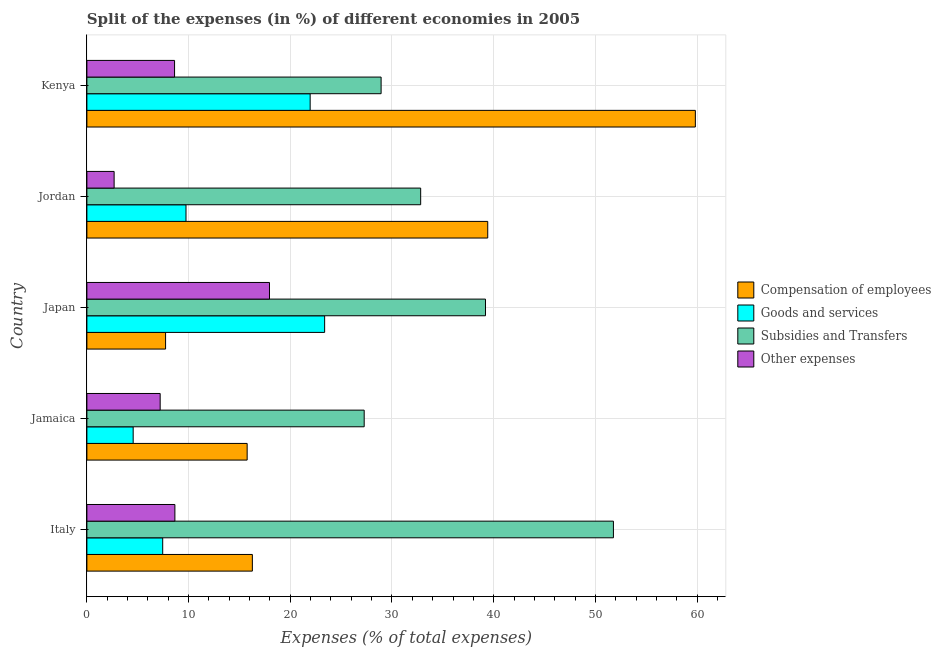Are the number of bars per tick equal to the number of legend labels?
Make the answer very short. Yes. How many bars are there on the 1st tick from the bottom?
Ensure brevity in your answer.  4. What is the label of the 4th group of bars from the top?
Your response must be concise. Jamaica. What is the percentage of amount spent on compensation of employees in Kenya?
Offer a terse response. 59.83. Across all countries, what is the maximum percentage of amount spent on goods and services?
Ensure brevity in your answer.  23.38. Across all countries, what is the minimum percentage of amount spent on compensation of employees?
Provide a succinct answer. 7.74. In which country was the percentage of amount spent on other expenses maximum?
Keep it short and to the point. Japan. In which country was the percentage of amount spent on other expenses minimum?
Ensure brevity in your answer.  Jordan. What is the total percentage of amount spent on goods and services in the graph?
Offer a very short reply. 67.08. What is the difference between the percentage of amount spent on goods and services in Jordan and that in Kenya?
Provide a short and direct response. -12.21. What is the difference between the percentage of amount spent on subsidies in Jordan and the percentage of amount spent on other expenses in Italy?
Keep it short and to the point. 24.17. What is the average percentage of amount spent on subsidies per country?
Make the answer very short. 36. What is the difference between the percentage of amount spent on subsidies and percentage of amount spent on other expenses in Jamaica?
Make the answer very short. 20.06. In how many countries, is the percentage of amount spent on subsidies greater than 54 %?
Provide a succinct answer. 0. What is the ratio of the percentage of amount spent on other expenses in Jordan to that in Kenya?
Ensure brevity in your answer.  0.31. Is the percentage of amount spent on goods and services in Jordan less than that in Kenya?
Ensure brevity in your answer.  Yes. What is the difference between the highest and the second highest percentage of amount spent on compensation of employees?
Make the answer very short. 20.42. What is the difference between the highest and the lowest percentage of amount spent on goods and services?
Offer a very short reply. 18.83. Is the sum of the percentage of amount spent on subsidies in Italy and Jordan greater than the maximum percentage of amount spent on goods and services across all countries?
Provide a succinct answer. Yes. Is it the case that in every country, the sum of the percentage of amount spent on compensation of employees and percentage of amount spent on other expenses is greater than the sum of percentage of amount spent on goods and services and percentage of amount spent on subsidies?
Give a very brief answer. Yes. What does the 2nd bar from the top in Italy represents?
Keep it short and to the point. Subsidies and Transfers. What does the 2nd bar from the bottom in Japan represents?
Provide a short and direct response. Goods and services. How many bars are there?
Provide a short and direct response. 20. Are all the bars in the graph horizontal?
Provide a short and direct response. Yes. What is the difference between two consecutive major ticks on the X-axis?
Give a very brief answer. 10. Does the graph contain any zero values?
Provide a succinct answer. No. Does the graph contain grids?
Offer a very short reply. Yes. Where does the legend appear in the graph?
Offer a terse response. Center right. How many legend labels are there?
Keep it short and to the point. 4. How are the legend labels stacked?
Provide a short and direct response. Vertical. What is the title of the graph?
Keep it short and to the point. Split of the expenses (in %) of different economies in 2005. Does "UNDP" appear as one of the legend labels in the graph?
Your answer should be compact. No. What is the label or title of the X-axis?
Keep it short and to the point. Expenses (% of total expenses). What is the label or title of the Y-axis?
Keep it short and to the point. Country. What is the Expenses (% of total expenses) in Compensation of employees in Italy?
Your response must be concise. 16.27. What is the Expenses (% of total expenses) in Goods and services in Italy?
Your answer should be compact. 7.46. What is the Expenses (% of total expenses) in Subsidies and Transfers in Italy?
Make the answer very short. 51.77. What is the Expenses (% of total expenses) in Other expenses in Italy?
Ensure brevity in your answer.  8.65. What is the Expenses (% of total expenses) in Compensation of employees in Jamaica?
Ensure brevity in your answer.  15.76. What is the Expenses (% of total expenses) of Goods and services in Jamaica?
Give a very brief answer. 4.55. What is the Expenses (% of total expenses) in Subsidies and Transfers in Jamaica?
Your answer should be compact. 27.27. What is the Expenses (% of total expenses) of Other expenses in Jamaica?
Offer a very short reply. 7.2. What is the Expenses (% of total expenses) in Compensation of employees in Japan?
Your answer should be very brief. 7.74. What is the Expenses (% of total expenses) of Goods and services in Japan?
Offer a terse response. 23.38. What is the Expenses (% of total expenses) in Subsidies and Transfers in Japan?
Give a very brief answer. 39.19. What is the Expenses (% of total expenses) of Other expenses in Japan?
Provide a short and direct response. 17.95. What is the Expenses (% of total expenses) in Compensation of employees in Jordan?
Your response must be concise. 39.41. What is the Expenses (% of total expenses) of Goods and services in Jordan?
Your answer should be very brief. 9.74. What is the Expenses (% of total expenses) of Subsidies and Transfers in Jordan?
Provide a short and direct response. 32.82. What is the Expenses (% of total expenses) of Other expenses in Jordan?
Your response must be concise. 2.68. What is the Expenses (% of total expenses) in Compensation of employees in Kenya?
Your answer should be compact. 59.83. What is the Expenses (% of total expenses) of Goods and services in Kenya?
Your response must be concise. 21.95. What is the Expenses (% of total expenses) of Subsidies and Transfers in Kenya?
Your answer should be compact. 28.93. What is the Expenses (% of total expenses) of Other expenses in Kenya?
Provide a succinct answer. 8.62. Across all countries, what is the maximum Expenses (% of total expenses) of Compensation of employees?
Offer a very short reply. 59.83. Across all countries, what is the maximum Expenses (% of total expenses) in Goods and services?
Provide a succinct answer. 23.38. Across all countries, what is the maximum Expenses (% of total expenses) in Subsidies and Transfers?
Provide a succinct answer. 51.77. Across all countries, what is the maximum Expenses (% of total expenses) of Other expenses?
Your answer should be compact. 17.95. Across all countries, what is the minimum Expenses (% of total expenses) of Compensation of employees?
Keep it short and to the point. 7.74. Across all countries, what is the minimum Expenses (% of total expenses) in Goods and services?
Your answer should be compact. 4.55. Across all countries, what is the minimum Expenses (% of total expenses) in Subsidies and Transfers?
Offer a very short reply. 27.27. Across all countries, what is the minimum Expenses (% of total expenses) in Other expenses?
Make the answer very short. 2.68. What is the total Expenses (% of total expenses) of Compensation of employees in the graph?
Provide a short and direct response. 139.01. What is the total Expenses (% of total expenses) of Goods and services in the graph?
Keep it short and to the point. 67.08. What is the total Expenses (% of total expenses) in Subsidies and Transfers in the graph?
Your answer should be very brief. 179.99. What is the total Expenses (% of total expenses) in Other expenses in the graph?
Your answer should be compact. 45.11. What is the difference between the Expenses (% of total expenses) in Compensation of employees in Italy and that in Jamaica?
Your answer should be compact. 0.51. What is the difference between the Expenses (% of total expenses) of Goods and services in Italy and that in Jamaica?
Make the answer very short. 2.9. What is the difference between the Expenses (% of total expenses) in Subsidies and Transfers in Italy and that in Jamaica?
Ensure brevity in your answer.  24.51. What is the difference between the Expenses (% of total expenses) in Other expenses in Italy and that in Jamaica?
Ensure brevity in your answer.  1.45. What is the difference between the Expenses (% of total expenses) in Compensation of employees in Italy and that in Japan?
Ensure brevity in your answer.  8.53. What is the difference between the Expenses (% of total expenses) in Goods and services in Italy and that in Japan?
Give a very brief answer. -15.92. What is the difference between the Expenses (% of total expenses) in Subsidies and Transfers in Italy and that in Japan?
Your response must be concise. 12.58. What is the difference between the Expenses (% of total expenses) of Other expenses in Italy and that in Japan?
Provide a short and direct response. -9.3. What is the difference between the Expenses (% of total expenses) in Compensation of employees in Italy and that in Jordan?
Keep it short and to the point. -23.14. What is the difference between the Expenses (% of total expenses) of Goods and services in Italy and that in Jordan?
Your answer should be very brief. -2.29. What is the difference between the Expenses (% of total expenses) in Subsidies and Transfers in Italy and that in Jordan?
Make the answer very short. 18.95. What is the difference between the Expenses (% of total expenses) of Other expenses in Italy and that in Jordan?
Offer a very short reply. 5.97. What is the difference between the Expenses (% of total expenses) of Compensation of employees in Italy and that in Kenya?
Offer a terse response. -43.56. What is the difference between the Expenses (% of total expenses) in Goods and services in Italy and that in Kenya?
Your response must be concise. -14.5. What is the difference between the Expenses (% of total expenses) in Subsidies and Transfers in Italy and that in Kenya?
Offer a terse response. 22.84. What is the difference between the Expenses (% of total expenses) of Other expenses in Italy and that in Kenya?
Your response must be concise. 0.03. What is the difference between the Expenses (% of total expenses) in Compensation of employees in Jamaica and that in Japan?
Your response must be concise. 8.02. What is the difference between the Expenses (% of total expenses) of Goods and services in Jamaica and that in Japan?
Ensure brevity in your answer.  -18.83. What is the difference between the Expenses (% of total expenses) in Subsidies and Transfers in Jamaica and that in Japan?
Keep it short and to the point. -11.93. What is the difference between the Expenses (% of total expenses) in Other expenses in Jamaica and that in Japan?
Keep it short and to the point. -10.75. What is the difference between the Expenses (% of total expenses) in Compensation of employees in Jamaica and that in Jordan?
Your answer should be very brief. -23.66. What is the difference between the Expenses (% of total expenses) of Goods and services in Jamaica and that in Jordan?
Offer a very short reply. -5.19. What is the difference between the Expenses (% of total expenses) in Subsidies and Transfers in Jamaica and that in Jordan?
Your answer should be very brief. -5.55. What is the difference between the Expenses (% of total expenses) of Other expenses in Jamaica and that in Jordan?
Make the answer very short. 4.53. What is the difference between the Expenses (% of total expenses) of Compensation of employees in Jamaica and that in Kenya?
Ensure brevity in your answer.  -44.07. What is the difference between the Expenses (% of total expenses) in Goods and services in Jamaica and that in Kenya?
Ensure brevity in your answer.  -17.4. What is the difference between the Expenses (% of total expenses) of Subsidies and Transfers in Jamaica and that in Kenya?
Keep it short and to the point. -1.66. What is the difference between the Expenses (% of total expenses) in Other expenses in Jamaica and that in Kenya?
Your answer should be very brief. -1.42. What is the difference between the Expenses (% of total expenses) of Compensation of employees in Japan and that in Jordan?
Provide a succinct answer. -31.68. What is the difference between the Expenses (% of total expenses) of Goods and services in Japan and that in Jordan?
Make the answer very short. 13.63. What is the difference between the Expenses (% of total expenses) in Subsidies and Transfers in Japan and that in Jordan?
Provide a succinct answer. 6.37. What is the difference between the Expenses (% of total expenses) in Other expenses in Japan and that in Jordan?
Your answer should be compact. 15.28. What is the difference between the Expenses (% of total expenses) in Compensation of employees in Japan and that in Kenya?
Offer a very short reply. -52.09. What is the difference between the Expenses (% of total expenses) in Goods and services in Japan and that in Kenya?
Your answer should be very brief. 1.43. What is the difference between the Expenses (% of total expenses) in Subsidies and Transfers in Japan and that in Kenya?
Give a very brief answer. 10.26. What is the difference between the Expenses (% of total expenses) in Other expenses in Japan and that in Kenya?
Ensure brevity in your answer.  9.33. What is the difference between the Expenses (% of total expenses) in Compensation of employees in Jordan and that in Kenya?
Your response must be concise. -20.42. What is the difference between the Expenses (% of total expenses) in Goods and services in Jordan and that in Kenya?
Keep it short and to the point. -12.21. What is the difference between the Expenses (% of total expenses) in Subsidies and Transfers in Jordan and that in Kenya?
Your answer should be compact. 3.89. What is the difference between the Expenses (% of total expenses) in Other expenses in Jordan and that in Kenya?
Your response must be concise. -5.94. What is the difference between the Expenses (% of total expenses) in Compensation of employees in Italy and the Expenses (% of total expenses) in Goods and services in Jamaica?
Your answer should be very brief. 11.72. What is the difference between the Expenses (% of total expenses) in Compensation of employees in Italy and the Expenses (% of total expenses) in Subsidies and Transfers in Jamaica?
Your response must be concise. -11. What is the difference between the Expenses (% of total expenses) in Compensation of employees in Italy and the Expenses (% of total expenses) in Other expenses in Jamaica?
Keep it short and to the point. 9.07. What is the difference between the Expenses (% of total expenses) in Goods and services in Italy and the Expenses (% of total expenses) in Subsidies and Transfers in Jamaica?
Keep it short and to the point. -19.81. What is the difference between the Expenses (% of total expenses) of Goods and services in Italy and the Expenses (% of total expenses) of Other expenses in Jamaica?
Your answer should be compact. 0.25. What is the difference between the Expenses (% of total expenses) of Subsidies and Transfers in Italy and the Expenses (% of total expenses) of Other expenses in Jamaica?
Give a very brief answer. 44.57. What is the difference between the Expenses (% of total expenses) of Compensation of employees in Italy and the Expenses (% of total expenses) of Goods and services in Japan?
Offer a terse response. -7.11. What is the difference between the Expenses (% of total expenses) of Compensation of employees in Italy and the Expenses (% of total expenses) of Subsidies and Transfers in Japan?
Ensure brevity in your answer.  -22.92. What is the difference between the Expenses (% of total expenses) in Compensation of employees in Italy and the Expenses (% of total expenses) in Other expenses in Japan?
Your answer should be compact. -1.68. What is the difference between the Expenses (% of total expenses) in Goods and services in Italy and the Expenses (% of total expenses) in Subsidies and Transfers in Japan?
Keep it short and to the point. -31.74. What is the difference between the Expenses (% of total expenses) in Goods and services in Italy and the Expenses (% of total expenses) in Other expenses in Japan?
Offer a terse response. -10.5. What is the difference between the Expenses (% of total expenses) in Subsidies and Transfers in Italy and the Expenses (% of total expenses) in Other expenses in Japan?
Offer a terse response. 33.82. What is the difference between the Expenses (% of total expenses) of Compensation of employees in Italy and the Expenses (% of total expenses) of Goods and services in Jordan?
Make the answer very short. 6.53. What is the difference between the Expenses (% of total expenses) in Compensation of employees in Italy and the Expenses (% of total expenses) in Subsidies and Transfers in Jordan?
Give a very brief answer. -16.55. What is the difference between the Expenses (% of total expenses) in Compensation of employees in Italy and the Expenses (% of total expenses) in Other expenses in Jordan?
Keep it short and to the point. 13.59. What is the difference between the Expenses (% of total expenses) in Goods and services in Italy and the Expenses (% of total expenses) in Subsidies and Transfers in Jordan?
Give a very brief answer. -25.37. What is the difference between the Expenses (% of total expenses) of Goods and services in Italy and the Expenses (% of total expenses) of Other expenses in Jordan?
Your response must be concise. 4.78. What is the difference between the Expenses (% of total expenses) of Subsidies and Transfers in Italy and the Expenses (% of total expenses) of Other expenses in Jordan?
Provide a succinct answer. 49.1. What is the difference between the Expenses (% of total expenses) of Compensation of employees in Italy and the Expenses (% of total expenses) of Goods and services in Kenya?
Your answer should be compact. -5.68. What is the difference between the Expenses (% of total expenses) of Compensation of employees in Italy and the Expenses (% of total expenses) of Subsidies and Transfers in Kenya?
Keep it short and to the point. -12.66. What is the difference between the Expenses (% of total expenses) of Compensation of employees in Italy and the Expenses (% of total expenses) of Other expenses in Kenya?
Provide a succinct answer. 7.65. What is the difference between the Expenses (% of total expenses) in Goods and services in Italy and the Expenses (% of total expenses) in Subsidies and Transfers in Kenya?
Provide a succinct answer. -21.47. What is the difference between the Expenses (% of total expenses) in Goods and services in Italy and the Expenses (% of total expenses) in Other expenses in Kenya?
Your response must be concise. -1.17. What is the difference between the Expenses (% of total expenses) of Subsidies and Transfers in Italy and the Expenses (% of total expenses) of Other expenses in Kenya?
Provide a succinct answer. 43.15. What is the difference between the Expenses (% of total expenses) of Compensation of employees in Jamaica and the Expenses (% of total expenses) of Goods and services in Japan?
Keep it short and to the point. -7.62. What is the difference between the Expenses (% of total expenses) of Compensation of employees in Jamaica and the Expenses (% of total expenses) of Subsidies and Transfers in Japan?
Your answer should be compact. -23.44. What is the difference between the Expenses (% of total expenses) in Compensation of employees in Jamaica and the Expenses (% of total expenses) in Other expenses in Japan?
Your answer should be compact. -2.2. What is the difference between the Expenses (% of total expenses) in Goods and services in Jamaica and the Expenses (% of total expenses) in Subsidies and Transfers in Japan?
Give a very brief answer. -34.64. What is the difference between the Expenses (% of total expenses) of Goods and services in Jamaica and the Expenses (% of total expenses) of Other expenses in Japan?
Provide a succinct answer. -13.4. What is the difference between the Expenses (% of total expenses) in Subsidies and Transfers in Jamaica and the Expenses (% of total expenses) in Other expenses in Japan?
Offer a terse response. 9.31. What is the difference between the Expenses (% of total expenses) in Compensation of employees in Jamaica and the Expenses (% of total expenses) in Goods and services in Jordan?
Your answer should be compact. 6.01. What is the difference between the Expenses (% of total expenses) of Compensation of employees in Jamaica and the Expenses (% of total expenses) of Subsidies and Transfers in Jordan?
Provide a succinct answer. -17.06. What is the difference between the Expenses (% of total expenses) in Compensation of employees in Jamaica and the Expenses (% of total expenses) in Other expenses in Jordan?
Your answer should be very brief. 13.08. What is the difference between the Expenses (% of total expenses) of Goods and services in Jamaica and the Expenses (% of total expenses) of Subsidies and Transfers in Jordan?
Make the answer very short. -28.27. What is the difference between the Expenses (% of total expenses) in Goods and services in Jamaica and the Expenses (% of total expenses) in Other expenses in Jordan?
Provide a short and direct response. 1.87. What is the difference between the Expenses (% of total expenses) in Subsidies and Transfers in Jamaica and the Expenses (% of total expenses) in Other expenses in Jordan?
Provide a succinct answer. 24.59. What is the difference between the Expenses (% of total expenses) in Compensation of employees in Jamaica and the Expenses (% of total expenses) in Goods and services in Kenya?
Your answer should be compact. -6.19. What is the difference between the Expenses (% of total expenses) of Compensation of employees in Jamaica and the Expenses (% of total expenses) of Subsidies and Transfers in Kenya?
Provide a succinct answer. -13.17. What is the difference between the Expenses (% of total expenses) of Compensation of employees in Jamaica and the Expenses (% of total expenses) of Other expenses in Kenya?
Your answer should be very brief. 7.14. What is the difference between the Expenses (% of total expenses) in Goods and services in Jamaica and the Expenses (% of total expenses) in Subsidies and Transfers in Kenya?
Give a very brief answer. -24.38. What is the difference between the Expenses (% of total expenses) in Goods and services in Jamaica and the Expenses (% of total expenses) in Other expenses in Kenya?
Keep it short and to the point. -4.07. What is the difference between the Expenses (% of total expenses) in Subsidies and Transfers in Jamaica and the Expenses (% of total expenses) in Other expenses in Kenya?
Provide a succinct answer. 18.65. What is the difference between the Expenses (% of total expenses) of Compensation of employees in Japan and the Expenses (% of total expenses) of Goods and services in Jordan?
Make the answer very short. -2.01. What is the difference between the Expenses (% of total expenses) in Compensation of employees in Japan and the Expenses (% of total expenses) in Subsidies and Transfers in Jordan?
Provide a succinct answer. -25.08. What is the difference between the Expenses (% of total expenses) in Compensation of employees in Japan and the Expenses (% of total expenses) in Other expenses in Jordan?
Offer a terse response. 5.06. What is the difference between the Expenses (% of total expenses) in Goods and services in Japan and the Expenses (% of total expenses) in Subsidies and Transfers in Jordan?
Provide a succinct answer. -9.44. What is the difference between the Expenses (% of total expenses) in Goods and services in Japan and the Expenses (% of total expenses) in Other expenses in Jordan?
Make the answer very short. 20.7. What is the difference between the Expenses (% of total expenses) of Subsidies and Transfers in Japan and the Expenses (% of total expenses) of Other expenses in Jordan?
Provide a succinct answer. 36.52. What is the difference between the Expenses (% of total expenses) in Compensation of employees in Japan and the Expenses (% of total expenses) in Goods and services in Kenya?
Ensure brevity in your answer.  -14.22. What is the difference between the Expenses (% of total expenses) of Compensation of employees in Japan and the Expenses (% of total expenses) of Subsidies and Transfers in Kenya?
Provide a succinct answer. -21.19. What is the difference between the Expenses (% of total expenses) of Compensation of employees in Japan and the Expenses (% of total expenses) of Other expenses in Kenya?
Provide a succinct answer. -0.88. What is the difference between the Expenses (% of total expenses) in Goods and services in Japan and the Expenses (% of total expenses) in Subsidies and Transfers in Kenya?
Give a very brief answer. -5.55. What is the difference between the Expenses (% of total expenses) in Goods and services in Japan and the Expenses (% of total expenses) in Other expenses in Kenya?
Provide a short and direct response. 14.76. What is the difference between the Expenses (% of total expenses) in Subsidies and Transfers in Japan and the Expenses (% of total expenses) in Other expenses in Kenya?
Give a very brief answer. 30.57. What is the difference between the Expenses (% of total expenses) of Compensation of employees in Jordan and the Expenses (% of total expenses) of Goods and services in Kenya?
Your response must be concise. 17.46. What is the difference between the Expenses (% of total expenses) of Compensation of employees in Jordan and the Expenses (% of total expenses) of Subsidies and Transfers in Kenya?
Your answer should be very brief. 10.48. What is the difference between the Expenses (% of total expenses) of Compensation of employees in Jordan and the Expenses (% of total expenses) of Other expenses in Kenya?
Your answer should be compact. 30.79. What is the difference between the Expenses (% of total expenses) of Goods and services in Jordan and the Expenses (% of total expenses) of Subsidies and Transfers in Kenya?
Keep it short and to the point. -19.18. What is the difference between the Expenses (% of total expenses) of Goods and services in Jordan and the Expenses (% of total expenses) of Other expenses in Kenya?
Provide a succinct answer. 1.12. What is the difference between the Expenses (% of total expenses) of Subsidies and Transfers in Jordan and the Expenses (% of total expenses) of Other expenses in Kenya?
Give a very brief answer. 24.2. What is the average Expenses (% of total expenses) of Compensation of employees per country?
Give a very brief answer. 27.8. What is the average Expenses (% of total expenses) in Goods and services per country?
Offer a very short reply. 13.42. What is the average Expenses (% of total expenses) in Subsidies and Transfers per country?
Provide a succinct answer. 36. What is the average Expenses (% of total expenses) of Other expenses per country?
Provide a short and direct response. 9.02. What is the difference between the Expenses (% of total expenses) of Compensation of employees and Expenses (% of total expenses) of Goods and services in Italy?
Give a very brief answer. 8.82. What is the difference between the Expenses (% of total expenses) in Compensation of employees and Expenses (% of total expenses) in Subsidies and Transfers in Italy?
Make the answer very short. -35.5. What is the difference between the Expenses (% of total expenses) of Compensation of employees and Expenses (% of total expenses) of Other expenses in Italy?
Keep it short and to the point. 7.62. What is the difference between the Expenses (% of total expenses) of Goods and services and Expenses (% of total expenses) of Subsidies and Transfers in Italy?
Give a very brief answer. -44.32. What is the difference between the Expenses (% of total expenses) in Goods and services and Expenses (% of total expenses) in Other expenses in Italy?
Your response must be concise. -1.2. What is the difference between the Expenses (% of total expenses) of Subsidies and Transfers and Expenses (% of total expenses) of Other expenses in Italy?
Offer a terse response. 43.12. What is the difference between the Expenses (% of total expenses) in Compensation of employees and Expenses (% of total expenses) in Goods and services in Jamaica?
Offer a very short reply. 11.21. What is the difference between the Expenses (% of total expenses) of Compensation of employees and Expenses (% of total expenses) of Subsidies and Transfers in Jamaica?
Your answer should be very brief. -11.51. What is the difference between the Expenses (% of total expenses) of Compensation of employees and Expenses (% of total expenses) of Other expenses in Jamaica?
Offer a terse response. 8.55. What is the difference between the Expenses (% of total expenses) of Goods and services and Expenses (% of total expenses) of Subsidies and Transfers in Jamaica?
Provide a short and direct response. -22.72. What is the difference between the Expenses (% of total expenses) in Goods and services and Expenses (% of total expenses) in Other expenses in Jamaica?
Your response must be concise. -2.65. What is the difference between the Expenses (% of total expenses) in Subsidies and Transfers and Expenses (% of total expenses) in Other expenses in Jamaica?
Your answer should be compact. 20.06. What is the difference between the Expenses (% of total expenses) of Compensation of employees and Expenses (% of total expenses) of Goods and services in Japan?
Your answer should be compact. -15.64. What is the difference between the Expenses (% of total expenses) in Compensation of employees and Expenses (% of total expenses) in Subsidies and Transfers in Japan?
Keep it short and to the point. -31.46. What is the difference between the Expenses (% of total expenses) in Compensation of employees and Expenses (% of total expenses) in Other expenses in Japan?
Keep it short and to the point. -10.22. What is the difference between the Expenses (% of total expenses) in Goods and services and Expenses (% of total expenses) in Subsidies and Transfers in Japan?
Ensure brevity in your answer.  -15.82. What is the difference between the Expenses (% of total expenses) of Goods and services and Expenses (% of total expenses) of Other expenses in Japan?
Give a very brief answer. 5.42. What is the difference between the Expenses (% of total expenses) of Subsidies and Transfers and Expenses (% of total expenses) of Other expenses in Japan?
Give a very brief answer. 21.24. What is the difference between the Expenses (% of total expenses) of Compensation of employees and Expenses (% of total expenses) of Goods and services in Jordan?
Give a very brief answer. 29.67. What is the difference between the Expenses (% of total expenses) in Compensation of employees and Expenses (% of total expenses) in Subsidies and Transfers in Jordan?
Provide a short and direct response. 6.59. What is the difference between the Expenses (% of total expenses) of Compensation of employees and Expenses (% of total expenses) of Other expenses in Jordan?
Your response must be concise. 36.74. What is the difference between the Expenses (% of total expenses) of Goods and services and Expenses (% of total expenses) of Subsidies and Transfers in Jordan?
Give a very brief answer. -23.08. What is the difference between the Expenses (% of total expenses) in Goods and services and Expenses (% of total expenses) in Other expenses in Jordan?
Offer a terse response. 7.07. What is the difference between the Expenses (% of total expenses) of Subsidies and Transfers and Expenses (% of total expenses) of Other expenses in Jordan?
Your answer should be very brief. 30.14. What is the difference between the Expenses (% of total expenses) in Compensation of employees and Expenses (% of total expenses) in Goods and services in Kenya?
Ensure brevity in your answer.  37.88. What is the difference between the Expenses (% of total expenses) of Compensation of employees and Expenses (% of total expenses) of Subsidies and Transfers in Kenya?
Provide a succinct answer. 30.9. What is the difference between the Expenses (% of total expenses) in Compensation of employees and Expenses (% of total expenses) in Other expenses in Kenya?
Ensure brevity in your answer.  51.21. What is the difference between the Expenses (% of total expenses) of Goods and services and Expenses (% of total expenses) of Subsidies and Transfers in Kenya?
Offer a terse response. -6.98. What is the difference between the Expenses (% of total expenses) of Goods and services and Expenses (% of total expenses) of Other expenses in Kenya?
Provide a succinct answer. 13.33. What is the difference between the Expenses (% of total expenses) in Subsidies and Transfers and Expenses (% of total expenses) in Other expenses in Kenya?
Your answer should be compact. 20.31. What is the ratio of the Expenses (% of total expenses) in Compensation of employees in Italy to that in Jamaica?
Make the answer very short. 1.03. What is the ratio of the Expenses (% of total expenses) in Goods and services in Italy to that in Jamaica?
Keep it short and to the point. 1.64. What is the ratio of the Expenses (% of total expenses) in Subsidies and Transfers in Italy to that in Jamaica?
Ensure brevity in your answer.  1.9. What is the ratio of the Expenses (% of total expenses) of Other expenses in Italy to that in Jamaica?
Keep it short and to the point. 1.2. What is the ratio of the Expenses (% of total expenses) in Compensation of employees in Italy to that in Japan?
Your answer should be compact. 2.1. What is the ratio of the Expenses (% of total expenses) in Goods and services in Italy to that in Japan?
Provide a succinct answer. 0.32. What is the ratio of the Expenses (% of total expenses) of Subsidies and Transfers in Italy to that in Japan?
Offer a terse response. 1.32. What is the ratio of the Expenses (% of total expenses) in Other expenses in Italy to that in Japan?
Provide a short and direct response. 0.48. What is the ratio of the Expenses (% of total expenses) of Compensation of employees in Italy to that in Jordan?
Your answer should be very brief. 0.41. What is the ratio of the Expenses (% of total expenses) of Goods and services in Italy to that in Jordan?
Your answer should be compact. 0.77. What is the ratio of the Expenses (% of total expenses) in Subsidies and Transfers in Italy to that in Jordan?
Give a very brief answer. 1.58. What is the ratio of the Expenses (% of total expenses) of Other expenses in Italy to that in Jordan?
Ensure brevity in your answer.  3.23. What is the ratio of the Expenses (% of total expenses) of Compensation of employees in Italy to that in Kenya?
Make the answer very short. 0.27. What is the ratio of the Expenses (% of total expenses) of Goods and services in Italy to that in Kenya?
Your response must be concise. 0.34. What is the ratio of the Expenses (% of total expenses) in Subsidies and Transfers in Italy to that in Kenya?
Offer a very short reply. 1.79. What is the ratio of the Expenses (% of total expenses) in Other expenses in Italy to that in Kenya?
Your response must be concise. 1. What is the ratio of the Expenses (% of total expenses) in Compensation of employees in Jamaica to that in Japan?
Your response must be concise. 2.04. What is the ratio of the Expenses (% of total expenses) in Goods and services in Jamaica to that in Japan?
Provide a short and direct response. 0.19. What is the ratio of the Expenses (% of total expenses) of Subsidies and Transfers in Jamaica to that in Japan?
Ensure brevity in your answer.  0.7. What is the ratio of the Expenses (% of total expenses) of Other expenses in Jamaica to that in Japan?
Your answer should be compact. 0.4. What is the ratio of the Expenses (% of total expenses) of Compensation of employees in Jamaica to that in Jordan?
Give a very brief answer. 0.4. What is the ratio of the Expenses (% of total expenses) of Goods and services in Jamaica to that in Jordan?
Your response must be concise. 0.47. What is the ratio of the Expenses (% of total expenses) of Subsidies and Transfers in Jamaica to that in Jordan?
Your answer should be compact. 0.83. What is the ratio of the Expenses (% of total expenses) in Other expenses in Jamaica to that in Jordan?
Offer a terse response. 2.69. What is the ratio of the Expenses (% of total expenses) of Compensation of employees in Jamaica to that in Kenya?
Offer a very short reply. 0.26. What is the ratio of the Expenses (% of total expenses) in Goods and services in Jamaica to that in Kenya?
Give a very brief answer. 0.21. What is the ratio of the Expenses (% of total expenses) of Subsidies and Transfers in Jamaica to that in Kenya?
Give a very brief answer. 0.94. What is the ratio of the Expenses (% of total expenses) in Other expenses in Jamaica to that in Kenya?
Provide a short and direct response. 0.84. What is the ratio of the Expenses (% of total expenses) in Compensation of employees in Japan to that in Jordan?
Your answer should be compact. 0.2. What is the ratio of the Expenses (% of total expenses) of Goods and services in Japan to that in Jordan?
Offer a terse response. 2.4. What is the ratio of the Expenses (% of total expenses) of Subsidies and Transfers in Japan to that in Jordan?
Provide a short and direct response. 1.19. What is the ratio of the Expenses (% of total expenses) in Other expenses in Japan to that in Jordan?
Ensure brevity in your answer.  6.71. What is the ratio of the Expenses (% of total expenses) of Compensation of employees in Japan to that in Kenya?
Your answer should be compact. 0.13. What is the ratio of the Expenses (% of total expenses) in Goods and services in Japan to that in Kenya?
Give a very brief answer. 1.06. What is the ratio of the Expenses (% of total expenses) in Subsidies and Transfers in Japan to that in Kenya?
Give a very brief answer. 1.35. What is the ratio of the Expenses (% of total expenses) in Other expenses in Japan to that in Kenya?
Offer a very short reply. 2.08. What is the ratio of the Expenses (% of total expenses) in Compensation of employees in Jordan to that in Kenya?
Provide a succinct answer. 0.66. What is the ratio of the Expenses (% of total expenses) of Goods and services in Jordan to that in Kenya?
Provide a succinct answer. 0.44. What is the ratio of the Expenses (% of total expenses) in Subsidies and Transfers in Jordan to that in Kenya?
Ensure brevity in your answer.  1.13. What is the ratio of the Expenses (% of total expenses) of Other expenses in Jordan to that in Kenya?
Give a very brief answer. 0.31. What is the difference between the highest and the second highest Expenses (% of total expenses) of Compensation of employees?
Provide a short and direct response. 20.42. What is the difference between the highest and the second highest Expenses (% of total expenses) in Goods and services?
Offer a very short reply. 1.43. What is the difference between the highest and the second highest Expenses (% of total expenses) of Subsidies and Transfers?
Your response must be concise. 12.58. What is the difference between the highest and the second highest Expenses (% of total expenses) of Other expenses?
Offer a very short reply. 9.3. What is the difference between the highest and the lowest Expenses (% of total expenses) in Compensation of employees?
Make the answer very short. 52.09. What is the difference between the highest and the lowest Expenses (% of total expenses) of Goods and services?
Your response must be concise. 18.83. What is the difference between the highest and the lowest Expenses (% of total expenses) in Subsidies and Transfers?
Provide a succinct answer. 24.51. What is the difference between the highest and the lowest Expenses (% of total expenses) of Other expenses?
Your answer should be compact. 15.28. 